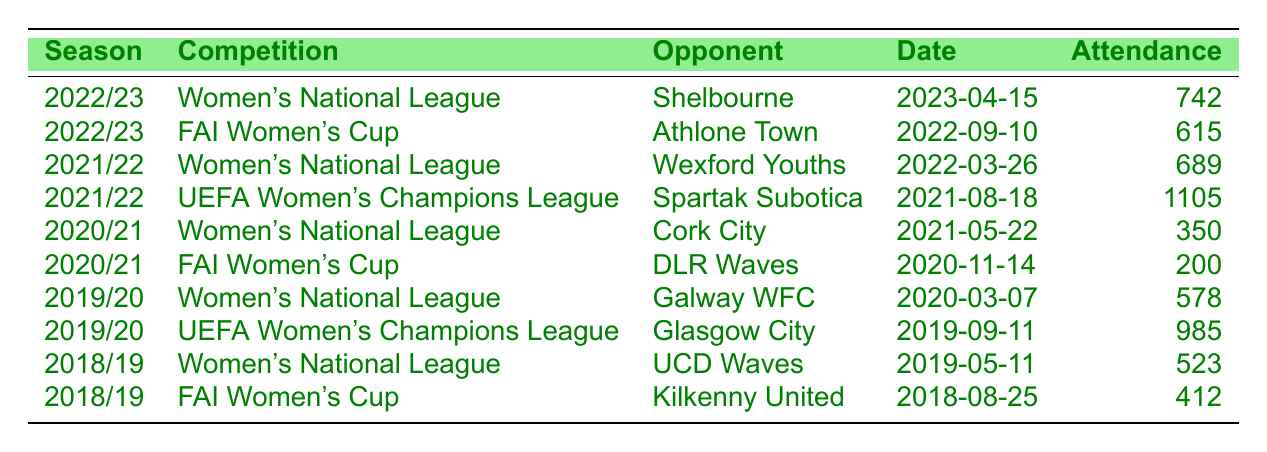What was the highest attendance for a Peamount United home game? The highest attendance is 1105, which occurred during the UEFA Women's Champions League match against Spartak Subotica on August 18, 2021.
Answer: 1105 During which season did Peamount United have the lowest attendance? The lowest attendance is 200, which happened during the FAI Women's Cup match against DLR Waves in the 2020/21 season.
Answer: 2020/21 What was the average attendance across all matches listed in the table? The total attendance is 742 + 615 + 689 + 1105 + 350 + 200 + 578 + 985 + 523 + 412 = 4909. There are 10 matches, so the average is 4909/10 = 490.9.
Answer: 490.9 How many matches had an attendance of over 700? There are four matches with attendances of over 700: (742, 689, 1105, 985).
Answer: 4 Did Peamount United play against Shelbourne in the 2021/22 season? No, the match against Shelbourne was in the 2022/23 season, not the 2021/22 season.
Answer: No Which competitor had the highest attendance recorded in the Women's National League? The highest attendance recorded in the Women's National League was 742 against Shelbourne in the 2022/23 season.
Answer: Shelbourne What is the total attendance from the home games played in 2019/20? The total attendance from the 2019/20 season is 578 (Galway WFC) + 985 (Glasgow City) = 1563.
Answer: 1563 Which season had the most matches listed in the table? The seasons 2022/23 and 2021/22 both have two matches listed each, while 2020/21 has two matches too, making them all equal.
Answer: 2022/23 and 2021/22 Was the attendance for the FAI Women's Cup game against Athlone Town greater than that against Kilkenny United? Yes, the attendance for the match against Athlone Town was 615, which is greater than the 412 attendance against Kilkenny United.
Answer: Yes Calculate the difference in attendance between the highest and lowest recorded attendances. The highest attendance is 1105, and the lowest is 200. The difference is 1105 - 200 = 905.
Answer: 905 